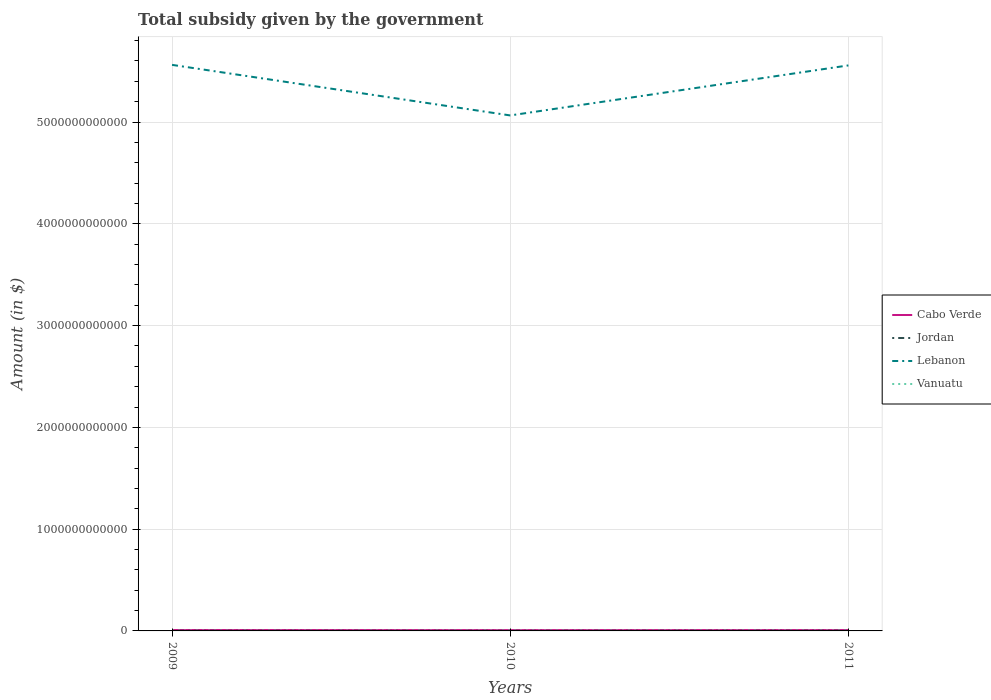Does the line corresponding to Vanuatu intersect with the line corresponding to Jordan?
Your response must be concise. No. Across all years, what is the maximum total revenue collected by the government in Vanuatu?
Offer a very short reply. 1.59e+09. What is the total total revenue collected by the government in Jordan in the graph?
Provide a short and direct response. -6.29e+08. What is the difference between the highest and the second highest total revenue collected by the government in Vanuatu?
Offer a terse response. 6.57e+08. Is the total revenue collected by the government in Vanuatu strictly greater than the total revenue collected by the government in Lebanon over the years?
Offer a terse response. Yes. How many lines are there?
Make the answer very short. 4. What is the difference between two consecutive major ticks on the Y-axis?
Ensure brevity in your answer.  1.00e+12. Are the values on the major ticks of Y-axis written in scientific E-notation?
Ensure brevity in your answer.  No. Does the graph contain grids?
Your answer should be very brief. Yes. Where does the legend appear in the graph?
Provide a short and direct response. Center right. How many legend labels are there?
Give a very brief answer. 4. What is the title of the graph?
Give a very brief answer. Total subsidy given by the government. Does "Australia" appear as one of the legend labels in the graph?
Give a very brief answer. No. What is the label or title of the Y-axis?
Make the answer very short. Amount (in $). What is the Amount (in $) in Cabo Verde in 2009?
Your response must be concise. 9.11e+09. What is the Amount (in $) of Jordan in 2009?
Your response must be concise. 1.52e+09. What is the Amount (in $) of Lebanon in 2009?
Offer a very short reply. 5.56e+12. What is the Amount (in $) of Vanuatu in 2009?
Offer a terse response. 1.59e+09. What is the Amount (in $) of Cabo Verde in 2010?
Make the answer very short. 8.20e+09. What is the Amount (in $) of Jordan in 2010?
Offer a very short reply. 1.36e+09. What is the Amount (in $) in Lebanon in 2010?
Your response must be concise. 5.06e+12. What is the Amount (in $) of Vanuatu in 2010?
Your answer should be compact. 1.92e+09. What is the Amount (in $) in Cabo Verde in 2011?
Keep it short and to the point. 8.55e+09. What is the Amount (in $) in Jordan in 2011?
Ensure brevity in your answer.  2.15e+09. What is the Amount (in $) in Lebanon in 2011?
Your answer should be very brief. 5.56e+12. What is the Amount (in $) of Vanuatu in 2011?
Provide a succinct answer. 2.24e+09. Across all years, what is the maximum Amount (in $) of Cabo Verde?
Your answer should be very brief. 9.11e+09. Across all years, what is the maximum Amount (in $) in Jordan?
Keep it short and to the point. 2.15e+09. Across all years, what is the maximum Amount (in $) of Lebanon?
Offer a very short reply. 5.56e+12. Across all years, what is the maximum Amount (in $) of Vanuatu?
Your answer should be very brief. 2.24e+09. Across all years, what is the minimum Amount (in $) in Cabo Verde?
Offer a terse response. 8.20e+09. Across all years, what is the minimum Amount (in $) of Jordan?
Offer a very short reply. 1.36e+09. Across all years, what is the minimum Amount (in $) in Lebanon?
Keep it short and to the point. 5.06e+12. Across all years, what is the minimum Amount (in $) in Vanuatu?
Ensure brevity in your answer.  1.59e+09. What is the total Amount (in $) of Cabo Verde in the graph?
Make the answer very short. 2.59e+1. What is the total Amount (in $) of Jordan in the graph?
Provide a short and direct response. 5.03e+09. What is the total Amount (in $) of Lebanon in the graph?
Your answer should be compact. 1.62e+13. What is the total Amount (in $) in Vanuatu in the graph?
Ensure brevity in your answer.  5.75e+09. What is the difference between the Amount (in $) in Cabo Verde in 2009 and that in 2010?
Provide a succinct answer. 9.08e+08. What is the difference between the Amount (in $) in Jordan in 2009 and that in 2010?
Keep it short and to the point. 1.57e+08. What is the difference between the Amount (in $) in Lebanon in 2009 and that in 2010?
Your answer should be compact. 4.97e+11. What is the difference between the Amount (in $) in Vanuatu in 2009 and that in 2010?
Offer a terse response. -3.33e+08. What is the difference between the Amount (in $) of Cabo Verde in 2009 and that in 2011?
Offer a terse response. 5.60e+08. What is the difference between the Amount (in $) in Jordan in 2009 and that in 2011?
Keep it short and to the point. -6.29e+08. What is the difference between the Amount (in $) of Lebanon in 2009 and that in 2011?
Provide a succinct answer. 5.30e+09. What is the difference between the Amount (in $) of Vanuatu in 2009 and that in 2011?
Your answer should be very brief. -6.57e+08. What is the difference between the Amount (in $) of Cabo Verde in 2010 and that in 2011?
Make the answer very short. -3.49e+08. What is the difference between the Amount (in $) in Jordan in 2010 and that in 2011?
Provide a succinct answer. -7.86e+08. What is the difference between the Amount (in $) of Lebanon in 2010 and that in 2011?
Give a very brief answer. -4.91e+11. What is the difference between the Amount (in $) in Vanuatu in 2010 and that in 2011?
Offer a very short reply. -3.24e+08. What is the difference between the Amount (in $) in Cabo Verde in 2009 and the Amount (in $) in Jordan in 2010?
Ensure brevity in your answer.  7.75e+09. What is the difference between the Amount (in $) in Cabo Verde in 2009 and the Amount (in $) in Lebanon in 2010?
Offer a very short reply. -5.06e+12. What is the difference between the Amount (in $) in Cabo Verde in 2009 and the Amount (in $) in Vanuatu in 2010?
Offer a terse response. 7.19e+09. What is the difference between the Amount (in $) of Jordan in 2009 and the Amount (in $) of Lebanon in 2010?
Offer a very short reply. -5.06e+12. What is the difference between the Amount (in $) in Jordan in 2009 and the Amount (in $) in Vanuatu in 2010?
Offer a very short reply. -4.03e+08. What is the difference between the Amount (in $) of Lebanon in 2009 and the Amount (in $) of Vanuatu in 2010?
Provide a short and direct response. 5.56e+12. What is the difference between the Amount (in $) of Cabo Verde in 2009 and the Amount (in $) of Jordan in 2011?
Keep it short and to the point. 6.96e+09. What is the difference between the Amount (in $) in Cabo Verde in 2009 and the Amount (in $) in Lebanon in 2011?
Offer a terse response. -5.55e+12. What is the difference between the Amount (in $) of Cabo Verde in 2009 and the Amount (in $) of Vanuatu in 2011?
Provide a succinct answer. 6.86e+09. What is the difference between the Amount (in $) of Jordan in 2009 and the Amount (in $) of Lebanon in 2011?
Your answer should be very brief. -5.55e+12. What is the difference between the Amount (in $) of Jordan in 2009 and the Amount (in $) of Vanuatu in 2011?
Make the answer very short. -7.27e+08. What is the difference between the Amount (in $) in Lebanon in 2009 and the Amount (in $) in Vanuatu in 2011?
Offer a very short reply. 5.56e+12. What is the difference between the Amount (in $) of Cabo Verde in 2010 and the Amount (in $) of Jordan in 2011?
Ensure brevity in your answer.  6.05e+09. What is the difference between the Amount (in $) of Cabo Verde in 2010 and the Amount (in $) of Lebanon in 2011?
Your response must be concise. -5.55e+12. What is the difference between the Amount (in $) in Cabo Verde in 2010 and the Amount (in $) in Vanuatu in 2011?
Offer a terse response. 5.95e+09. What is the difference between the Amount (in $) in Jordan in 2010 and the Amount (in $) in Lebanon in 2011?
Give a very brief answer. -5.55e+12. What is the difference between the Amount (in $) in Jordan in 2010 and the Amount (in $) in Vanuatu in 2011?
Your answer should be compact. -8.83e+08. What is the difference between the Amount (in $) in Lebanon in 2010 and the Amount (in $) in Vanuatu in 2011?
Offer a terse response. 5.06e+12. What is the average Amount (in $) of Cabo Verde per year?
Ensure brevity in your answer.  8.62e+09. What is the average Amount (in $) in Jordan per year?
Provide a succinct answer. 1.68e+09. What is the average Amount (in $) of Lebanon per year?
Give a very brief answer. 5.39e+12. What is the average Amount (in $) in Vanuatu per year?
Provide a short and direct response. 1.92e+09. In the year 2009, what is the difference between the Amount (in $) of Cabo Verde and Amount (in $) of Jordan?
Your answer should be compact. 7.59e+09. In the year 2009, what is the difference between the Amount (in $) in Cabo Verde and Amount (in $) in Lebanon?
Your response must be concise. -5.55e+12. In the year 2009, what is the difference between the Amount (in $) of Cabo Verde and Amount (in $) of Vanuatu?
Offer a very short reply. 7.52e+09. In the year 2009, what is the difference between the Amount (in $) of Jordan and Amount (in $) of Lebanon?
Keep it short and to the point. -5.56e+12. In the year 2009, what is the difference between the Amount (in $) of Jordan and Amount (in $) of Vanuatu?
Offer a very short reply. -7.02e+07. In the year 2009, what is the difference between the Amount (in $) in Lebanon and Amount (in $) in Vanuatu?
Your response must be concise. 5.56e+12. In the year 2010, what is the difference between the Amount (in $) of Cabo Verde and Amount (in $) of Jordan?
Give a very brief answer. 6.84e+09. In the year 2010, what is the difference between the Amount (in $) of Cabo Verde and Amount (in $) of Lebanon?
Give a very brief answer. -5.06e+12. In the year 2010, what is the difference between the Amount (in $) in Cabo Verde and Amount (in $) in Vanuatu?
Keep it short and to the point. 6.28e+09. In the year 2010, what is the difference between the Amount (in $) of Jordan and Amount (in $) of Lebanon?
Offer a terse response. -5.06e+12. In the year 2010, what is the difference between the Amount (in $) in Jordan and Amount (in $) in Vanuatu?
Make the answer very short. -5.59e+08. In the year 2010, what is the difference between the Amount (in $) in Lebanon and Amount (in $) in Vanuatu?
Offer a very short reply. 5.06e+12. In the year 2011, what is the difference between the Amount (in $) in Cabo Verde and Amount (in $) in Jordan?
Your answer should be very brief. 6.40e+09. In the year 2011, what is the difference between the Amount (in $) of Cabo Verde and Amount (in $) of Lebanon?
Your response must be concise. -5.55e+12. In the year 2011, what is the difference between the Amount (in $) of Cabo Verde and Amount (in $) of Vanuatu?
Your answer should be compact. 6.30e+09. In the year 2011, what is the difference between the Amount (in $) of Jordan and Amount (in $) of Lebanon?
Your answer should be compact. -5.55e+12. In the year 2011, what is the difference between the Amount (in $) in Jordan and Amount (in $) in Vanuatu?
Your response must be concise. -9.77e+07. In the year 2011, what is the difference between the Amount (in $) of Lebanon and Amount (in $) of Vanuatu?
Provide a short and direct response. 5.55e+12. What is the ratio of the Amount (in $) in Cabo Verde in 2009 to that in 2010?
Provide a short and direct response. 1.11. What is the ratio of the Amount (in $) in Jordan in 2009 to that in 2010?
Provide a succinct answer. 1.12. What is the ratio of the Amount (in $) in Lebanon in 2009 to that in 2010?
Offer a terse response. 1.1. What is the ratio of the Amount (in $) of Vanuatu in 2009 to that in 2010?
Your answer should be compact. 0.83. What is the ratio of the Amount (in $) of Cabo Verde in 2009 to that in 2011?
Keep it short and to the point. 1.07. What is the ratio of the Amount (in $) in Jordan in 2009 to that in 2011?
Give a very brief answer. 0.71. What is the ratio of the Amount (in $) of Vanuatu in 2009 to that in 2011?
Give a very brief answer. 0.71. What is the ratio of the Amount (in $) of Cabo Verde in 2010 to that in 2011?
Ensure brevity in your answer.  0.96. What is the ratio of the Amount (in $) in Jordan in 2010 to that in 2011?
Ensure brevity in your answer.  0.63. What is the ratio of the Amount (in $) in Lebanon in 2010 to that in 2011?
Your response must be concise. 0.91. What is the ratio of the Amount (in $) of Vanuatu in 2010 to that in 2011?
Offer a very short reply. 0.86. What is the difference between the highest and the second highest Amount (in $) in Cabo Verde?
Give a very brief answer. 5.60e+08. What is the difference between the highest and the second highest Amount (in $) of Jordan?
Provide a short and direct response. 6.29e+08. What is the difference between the highest and the second highest Amount (in $) in Lebanon?
Your answer should be very brief. 5.30e+09. What is the difference between the highest and the second highest Amount (in $) of Vanuatu?
Your answer should be very brief. 3.24e+08. What is the difference between the highest and the lowest Amount (in $) of Cabo Verde?
Keep it short and to the point. 9.08e+08. What is the difference between the highest and the lowest Amount (in $) of Jordan?
Provide a succinct answer. 7.86e+08. What is the difference between the highest and the lowest Amount (in $) of Lebanon?
Offer a very short reply. 4.97e+11. What is the difference between the highest and the lowest Amount (in $) in Vanuatu?
Ensure brevity in your answer.  6.57e+08. 